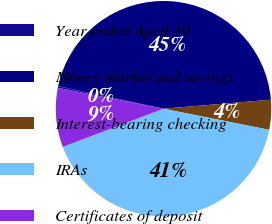Convert chart. <chart><loc_0><loc_0><loc_500><loc_500><pie_chart><fcel>Year ended April 30<fcel>Money market and savings<fcel>Interest-bearing checking<fcel>IRAs<fcel>Certificates of deposit<nl><fcel>0.26%<fcel>45.31%<fcel>4.47%<fcel>41.1%<fcel>8.86%<nl></chart> 